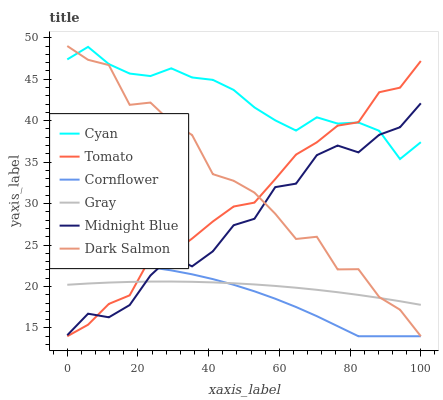Does Cornflower have the minimum area under the curve?
Answer yes or no. Yes. Does Cyan have the maximum area under the curve?
Answer yes or no. Yes. Does Gray have the minimum area under the curve?
Answer yes or no. No. Does Gray have the maximum area under the curve?
Answer yes or no. No. Is Gray the smoothest?
Answer yes or no. Yes. Is Dark Salmon the roughest?
Answer yes or no. Yes. Is Midnight Blue the smoothest?
Answer yes or no. No. Is Midnight Blue the roughest?
Answer yes or no. No. Does Tomato have the lowest value?
Answer yes or no. Yes. Does Gray have the lowest value?
Answer yes or no. No. Does Dark Salmon have the highest value?
Answer yes or no. Yes. Does Midnight Blue have the highest value?
Answer yes or no. No. Is Cornflower less than Cyan?
Answer yes or no. Yes. Is Cyan greater than Gray?
Answer yes or no. Yes. Does Cornflower intersect Tomato?
Answer yes or no. Yes. Is Cornflower less than Tomato?
Answer yes or no. No. Is Cornflower greater than Tomato?
Answer yes or no. No. Does Cornflower intersect Cyan?
Answer yes or no. No. 